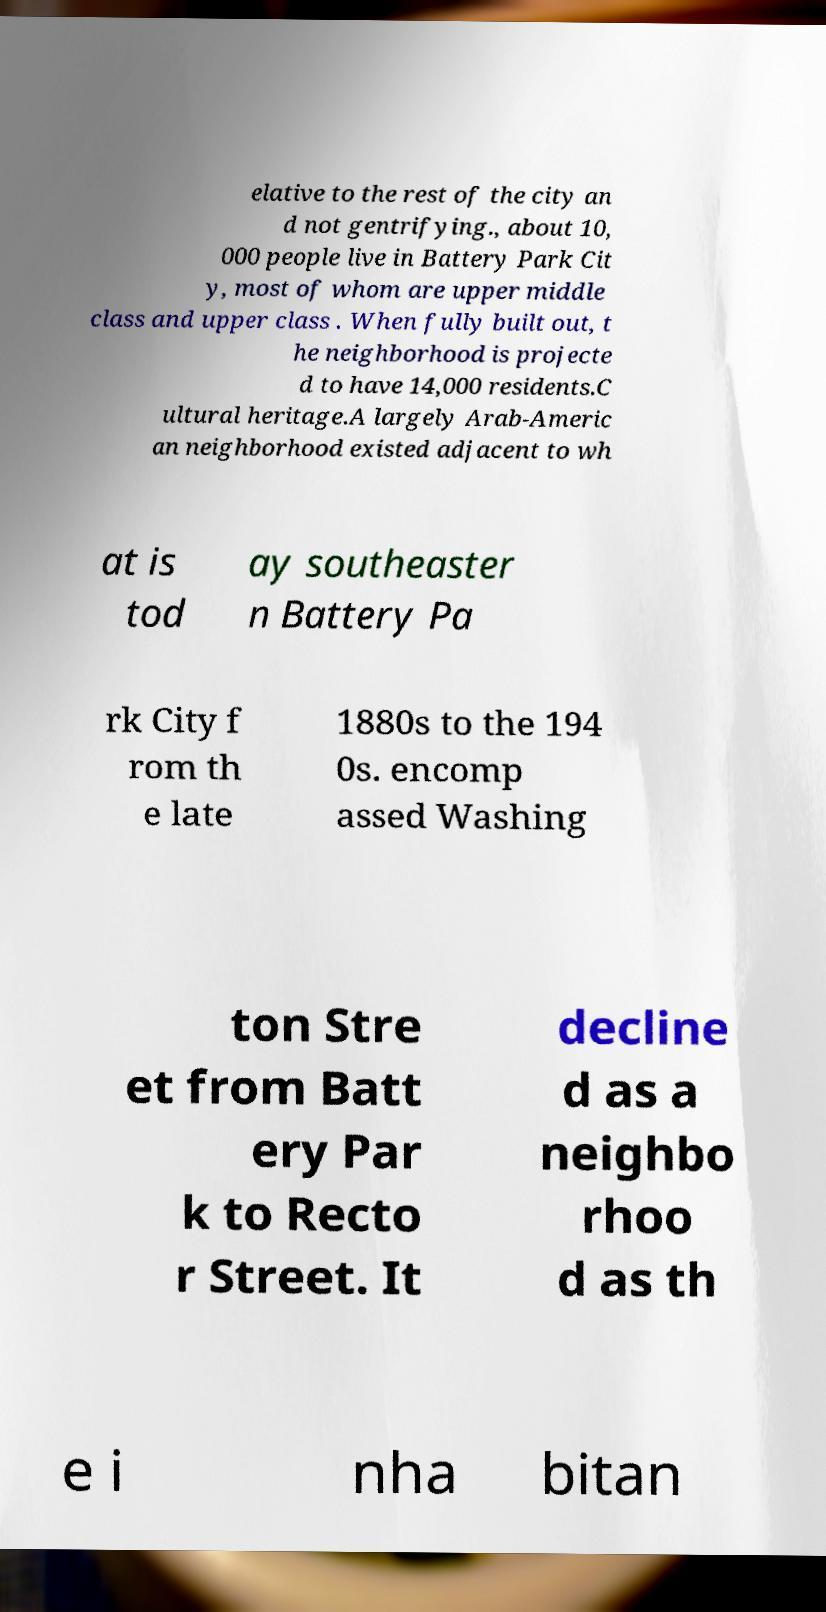Please identify and transcribe the text found in this image. elative to the rest of the city an d not gentrifying., about 10, 000 people live in Battery Park Cit y, most of whom are upper middle class and upper class . When fully built out, t he neighborhood is projecte d to have 14,000 residents.C ultural heritage.A largely Arab-Americ an neighborhood existed adjacent to wh at is tod ay southeaster n Battery Pa rk City f rom th e late 1880s to the 194 0s. encomp assed Washing ton Stre et from Batt ery Par k to Recto r Street. It decline d as a neighbo rhoo d as th e i nha bitan 